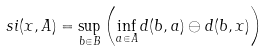Convert formula to latex. <formula><loc_0><loc_0><loc_500><loc_500>\ s i ( x , A ) = \sup _ { b \in B } \left ( \inf _ { a \in A } d ( b , a ) \ominus d ( b , x ) \right )</formula> 